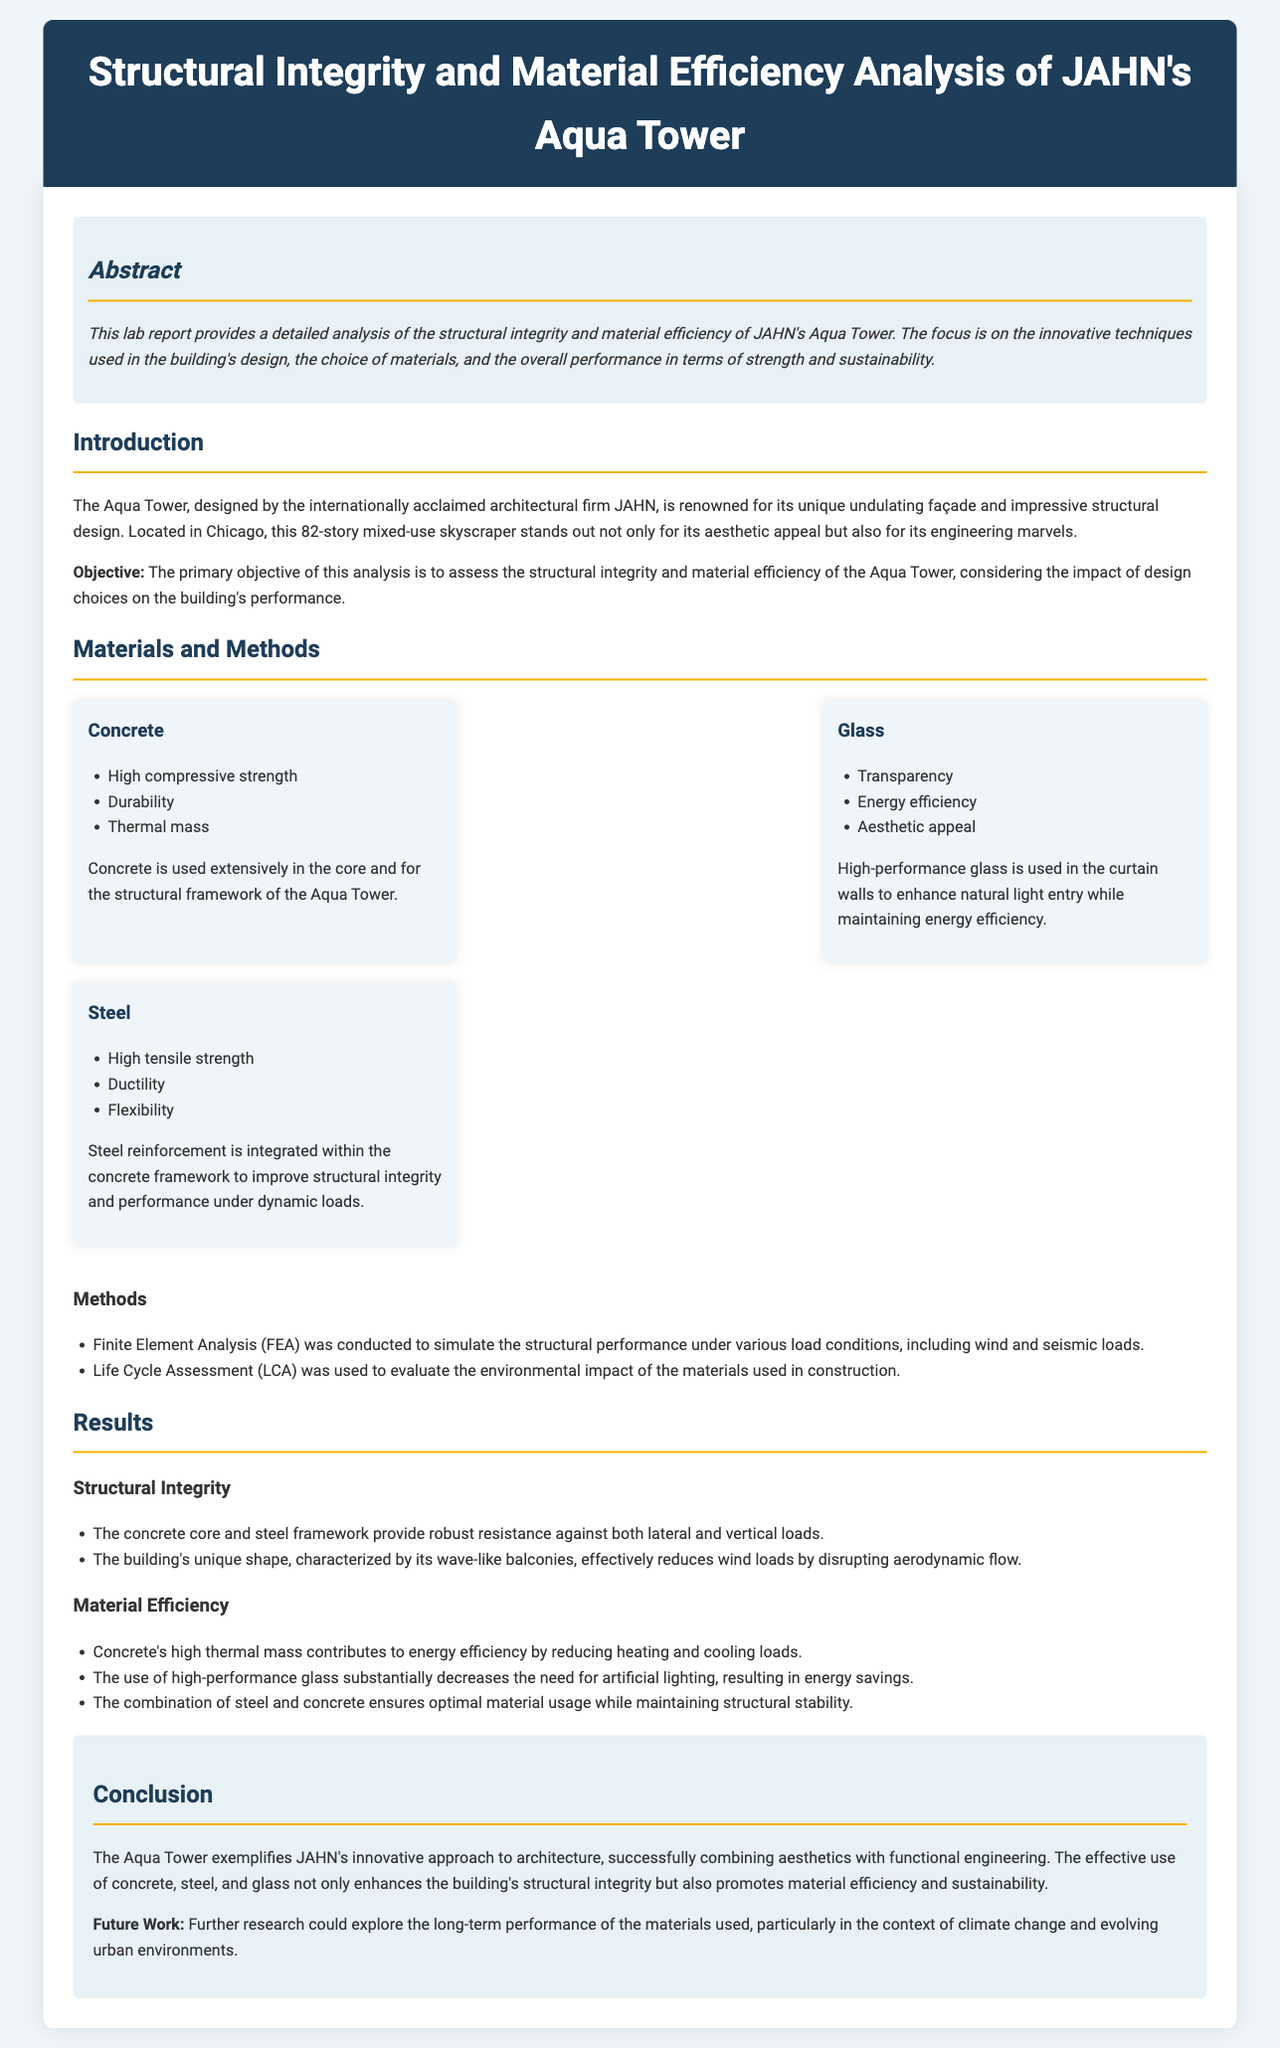What is the primary objective of this analysis? The primary objective is found in the introduction section, highlighting the goal to assess the structural integrity and material efficiency of the Aqua Tower.
Answer: to assess the structural integrity and material efficiency What are the three materials extensively discussed in the report? The materials are listed in the "Materials and Methods" section, clearly identifying concrete, glass, and steel as the three main materials.
Answer: Concrete, Glass, Steel Which methodology was used to evaluate environmental impact? The methods section specifies the use of Life Cycle Assessment to evaluate the environmental impact, indicating its importance in the analysis.
Answer: Life Cycle Assessment What is one benefit of using high-performance glass in Aqua Tower? The report mentions energy efficiency as a key benefit of high-performance glass, emphasizing its role in the building's design.
Answer: Energy efficiency How does the building's unique shape affect wind loads? The results section explains that the wave-like balconies disrupt aerodynamic flow, effectively reducing wind loads on the structure.
Answer: Reducing wind loads What type of analysis was conducted to simulate structural performance? The "Methods" section explicitly states that Finite Element Analysis (FEA) was used to simulate the structural performance under various load conditions.
Answer: Finite Element Analysis Which word describes the structural stability provided by the combination of steel and concrete? The results section discusses optimal material usage while maintaining structural stability, indicating a focus on efficient construction techniques.
Answer: Stability What is a potential area for future research mentioned in the conclusion? The conclusion outlines future research possibilities, particularly concerning long-term material performance in relation to climate change and urban environments.
Answer: Long-term performance of materials 